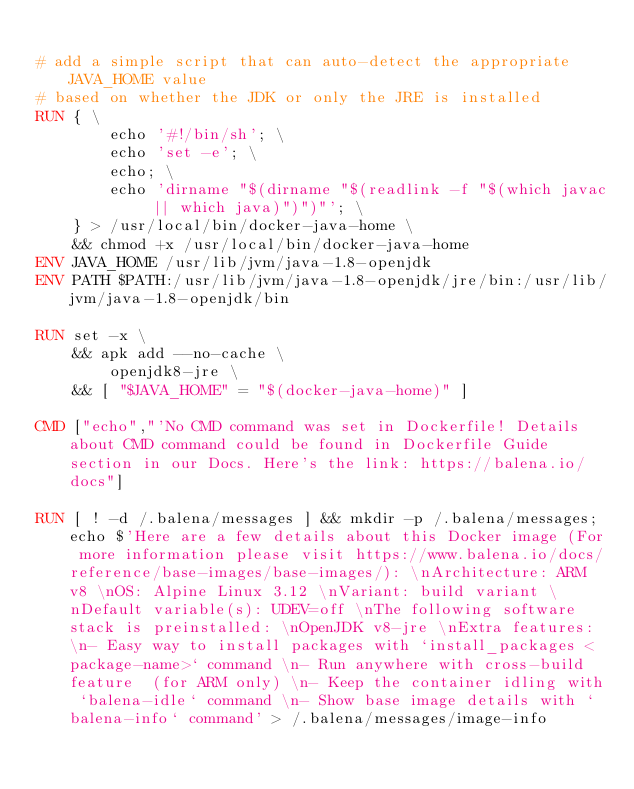<code> <loc_0><loc_0><loc_500><loc_500><_Dockerfile_>
# add a simple script that can auto-detect the appropriate JAVA_HOME value
# based on whether the JDK or only the JRE is installed
RUN { \
		echo '#!/bin/sh'; \
		echo 'set -e'; \
		echo; \
		echo 'dirname "$(dirname "$(readlink -f "$(which javac || which java)")")"'; \
	} > /usr/local/bin/docker-java-home \
	&& chmod +x /usr/local/bin/docker-java-home
ENV JAVA_HOME /usr/lib/jvm/java-1.8-openjdk
ENV PATH $PATH:/usr/lib/jvm/java-1.8-openjdk/jre/bin:/usr/lib/jvm/java-1.8-openjdk/bin

RUN set -x \
	&& apk add --no-cache \
		openjdk8-jre \
	&& [ "$JAVA_HOME" = "$(docker-java-home)" ]

CMD ["echo","'No CMD command was set in Dockerfile! Details about CMD command could be found in Dockerfile Guide section in our Docs. Here's the link: https://balena.io/docs"]

RUN [ ! -d /.balena/messages ] && mkdir -p /.balena/messages; echo $'Here are a few details about this Docker image (For more information please visit https://www.balena.io/docs/reference/base-images/base-images/): \nArchitecture: ARM v8 \nOS: Alpine Linux 3.12 \nVariant: build variant \nDefault variable(s): UDEV=off \nThe following software stack is preinstalled: \nOpenJDK v8-jre \nExtra features: \n- Easy way to install packages with `install_packages <package-name>` command \n- Run anywhere with cross-build feature  (for ARM only) \n- Keep the container idling with `balena-idle` command \n- Show base image details with `balena-info` command' > /.balena/messages/image-info</code> 